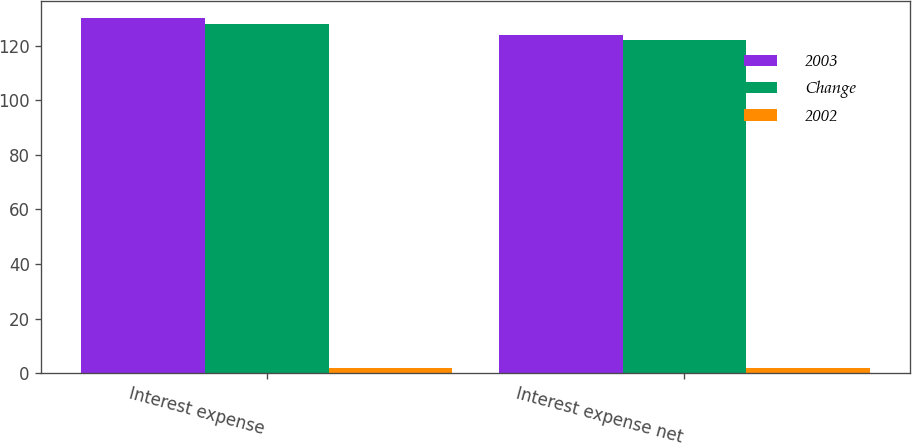<chart> <loc_0><loc_0><loc_500><loc_500><stacked_bar_chart><ecel><fcel>Interest expense<fcel>Interest expense net<nl><fcel>2003<fcel>130<fcel>124<nl><fcel>Change<fcel>128<fcel>122<nl><fcel>2002<fcel>2<fcel>2<nl></chart> 